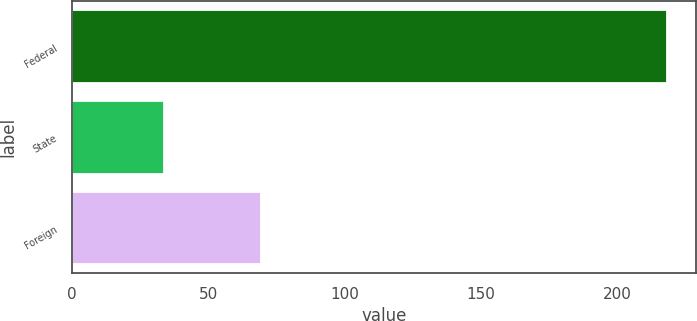<chart> <loc_0><loc_0><loc_500><loc_500><bar_chart><fcel>Federal<fcel>State<fcel>Foreign<nl><fcel>218.3<fcel>33.7<fcel>69.4<nl></chart> 